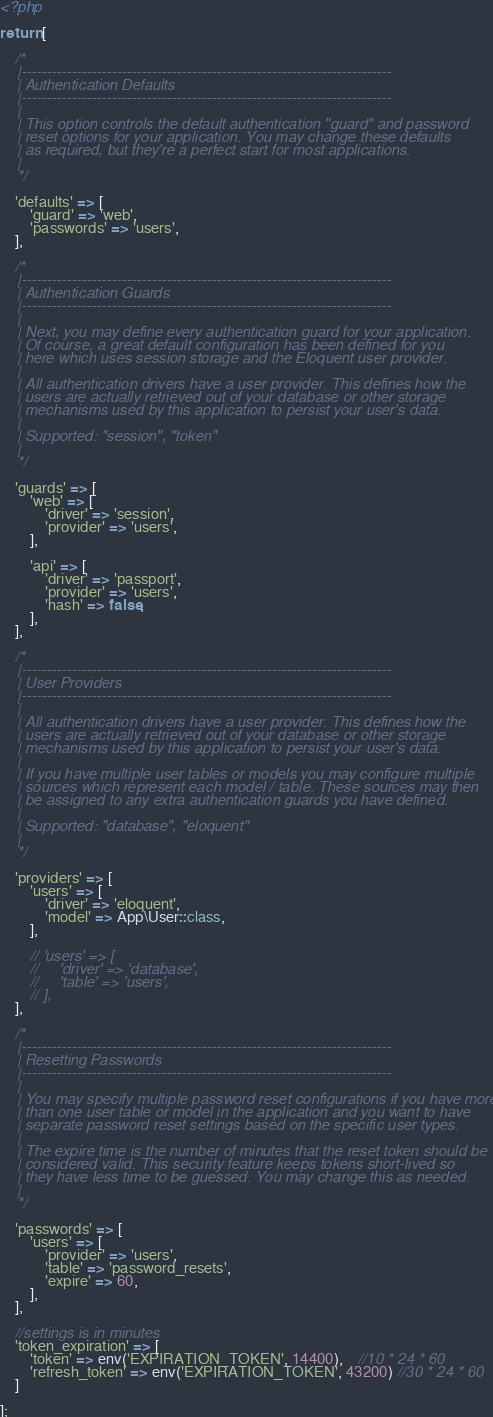Convert code to text. <code><loc_0><loc_0><loc_500><loc_500><_PHP_><?php

return [

    /*
    |--------------------------------------------------------------------------
    | Authentication Defaults
    |--------------------------------------------------------------------------
    |
    | This option controls the default authentication "guard" and password
    | reset options for your application. You may change these defaults
    | as required, but they're a perfect start for most applications.
    |
    */

    'defaults' => [
        'guard' => 'web',
        'passwords' => 'users',
    ],

    /*
    |--------------------------------------------------------------------------
    | Authentication Guards
    |--------------------------------------------------------------------------
    |
    | Next, you may define every authentication guard for your application.
    | Of course, a great default configuration has been defined for you
    | here which uses session storage and the Eloquent user provider.
    |
    | All authentication drivers have a user provider. This defines how the
    | users are actually retrieved out of your database or other storage
    | mechanisms used by this application to persist your user's data.
    |
    | Supported: "session", "token"
    |
    */

    'guards' => [
        'web' => [
            'driver' => 'session',
            'provider' => 'users',
        ],

        'api' => [
            'driver' => 'passport',
            'provider' => 'users',
            'hash' => false,
        ],
    ],

    /*
    |--------------------------------------------------------------------------
    | User Providers
    |--------------------------------------------------------------------------
    |
    | All authentication drivers have a user provider. This defines how the
    | users are actually retrieved out of your database or other storage
    | mechanisms used by this application to persist your user's data.
    |
    | If you have multiple user tables or models you may configure multiple
    | sources which represent each model / table. These sources may then
    | be assigned to any extra authentication guards you have defined.
    |
    | Supported: "database", "eloquent"
    |
    */

    'providers' => [
        'users' => [
            'driver' => 'eloquent',
            'model' => App\User::class,
        ],

        // 'users' => [
        //     'driver' => 'database',
        //     'table' => 'users',
        // ],
    ],

    /*
    |--------------------------------------------------------------------------
    | Resetting Passwords
    |--------------------------------------------------------------------------
    |
    | You may specify multiple password reset configurations if you have more
    | than one user table or model in the application and you want to have
    | separate password reset settings based on the specific user types.
    |
    | The expire time is the number of minutes that the reset token should be
    | considered valid. This security feature keeps tokens short-lived so
    | they have less time to be guessed. You may change this as needed.
    |
    */

    'passwords' => [
        'users' => [
            'provider' => 'users',
            'table' => 'password_resets',
            'expire' => 60,
        ],
    ],

    //settings is in minutes
    'token_expiration' => [
        'token' => env('EXPIRATION_TOKEN', 14400),    //10 * 24 * 60
        'refresh_token' => env('EXPIRATION_TOKEN', 43200) //30 * 24 * 60
    ]

];
</code> 